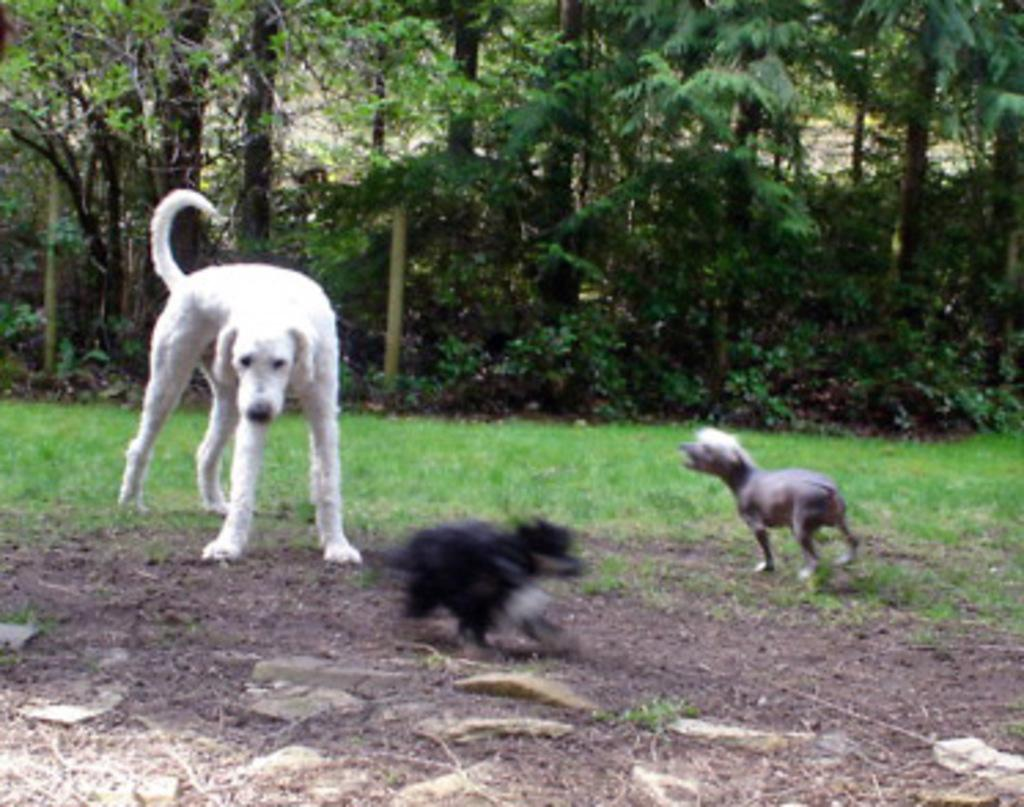What type of animal can be seen in the image? There is a dog in the image. How many other animals are present in the image? There are two other animals in the image. What is the ground covered with in the image? There is grass on the ground in the image. What can be seen in the background of the image? There are trees in the background of the image. What type of iron can be seen in the image? There is no iron present in the image. Is there a print of a jar visible in the image? There is no jar or print of a jar present in the image. 